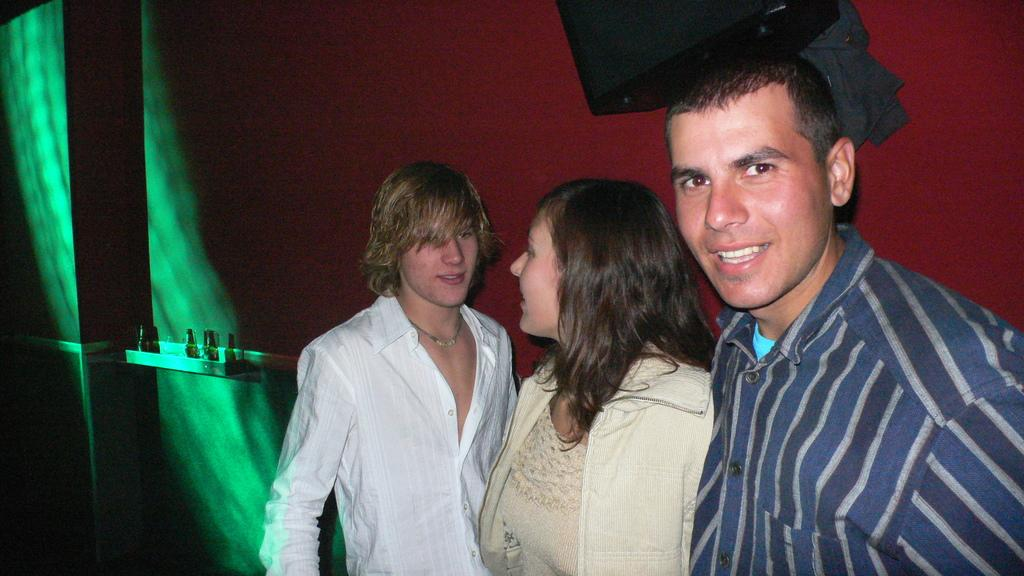How many individuals are present in the image? There are three people in the image. What can be seen in the background of the image? There is a wall and objects visible in the background of the image. What part of the bear's body can be seen in the image? There are no bears present in the image. 